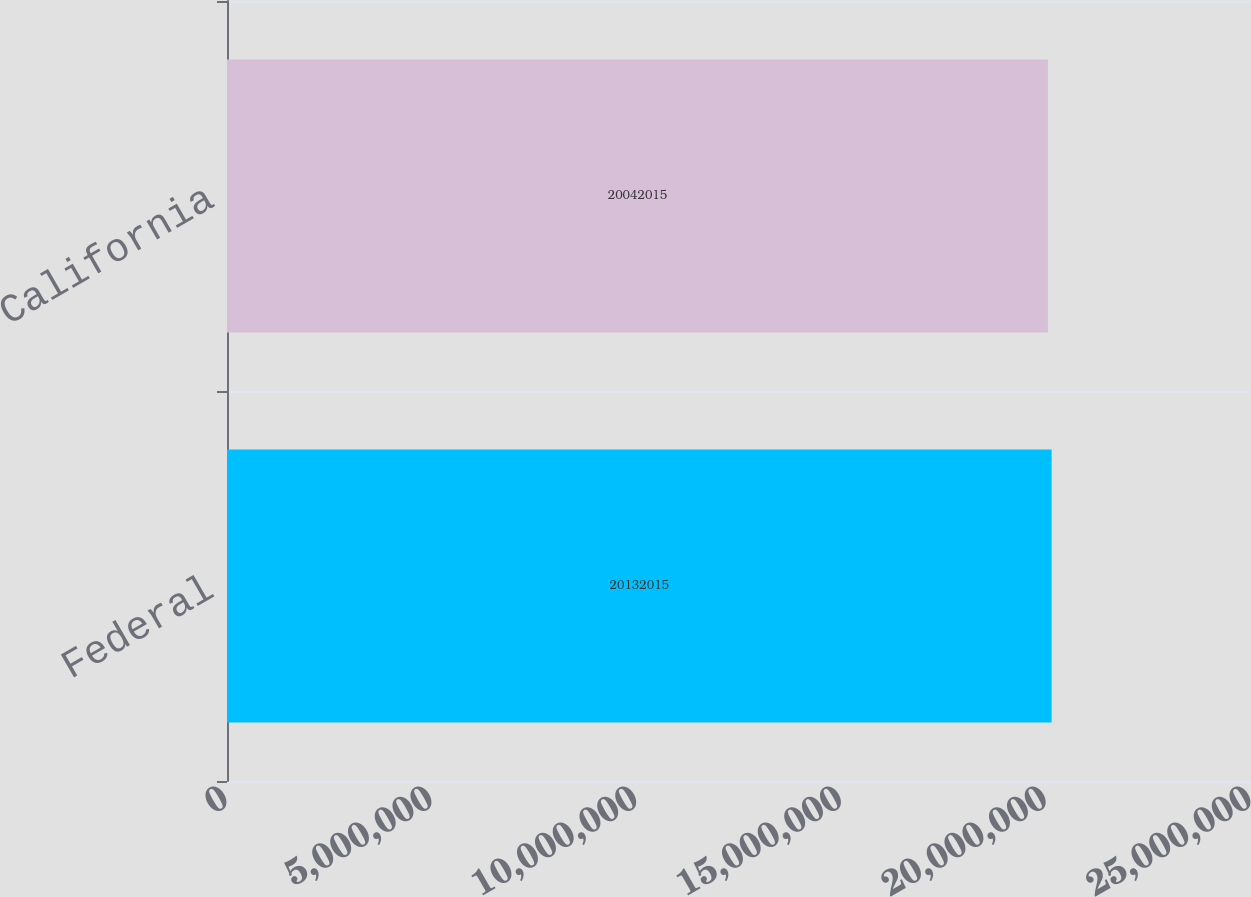<chart> <loc_0><loc_0><loc_500><loc_500><bar_chart><fcel>Federal<fcel>California<nl><fcel>2.0132e+07<fcel>2.0042e+07<nl></chart> 